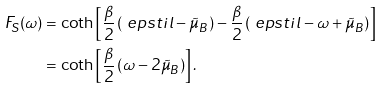Convert formula to latex. <formula><loc_0><loc_0><loc_500><loc_500>F _ { S } ( \omega ) & = \coth \left [ \frac { \beta } { 2 } \left ( \ e p s t i l - \tilde { \mu } _ { B } \right ) - \frac { \beta } { 2 } \left ( \ e p s t i l - \omega + \tilde { \mu } _ { B } \right ) \right ] \\ & = \coth \left [ \frac { \beta } { 2 } \left ( \omega - 2 \tilde { \mu } _ { B } \right ) \right ] .</formula> 